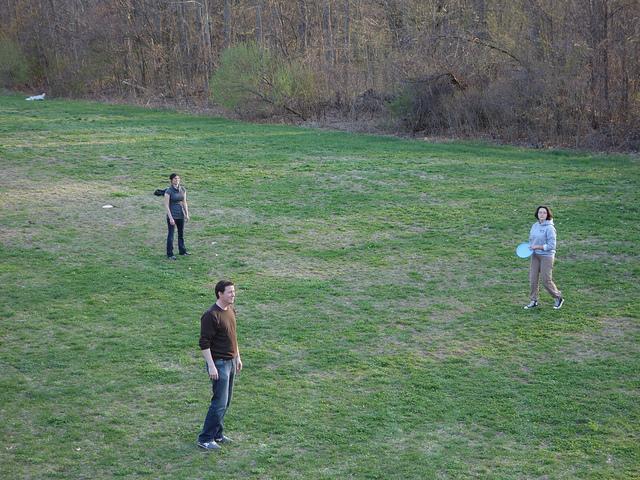How many people are pictured?
Give a very brief answer. 3. How many people can be seen?
Give a very brief answer. 2. How many elephants are in this photo?
Give a very brief answer. 0. 